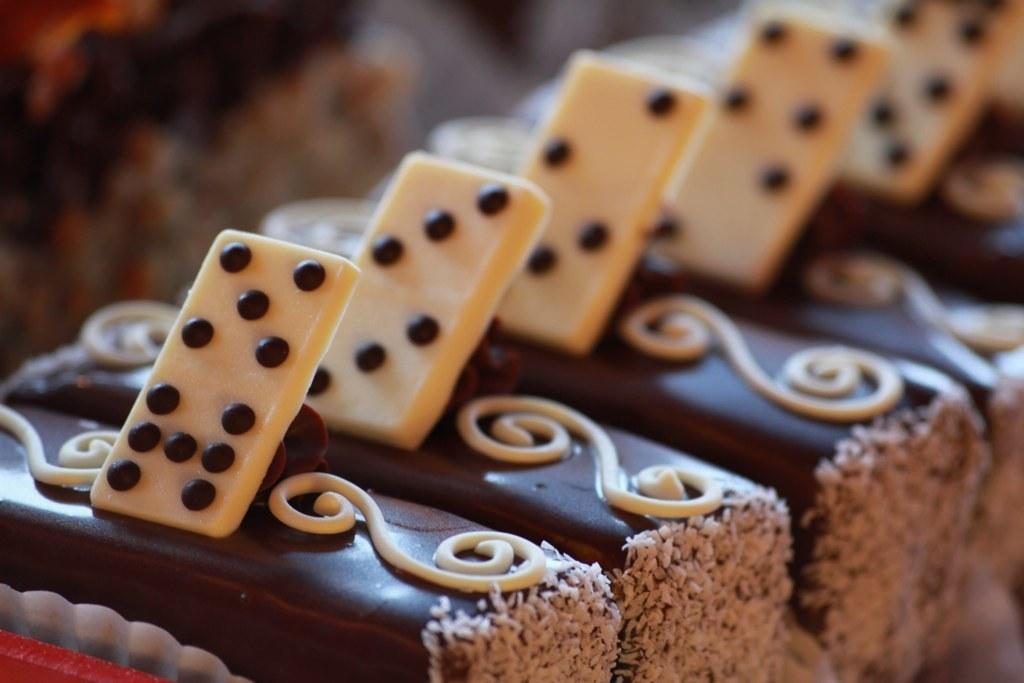Please provide a concise description of this image. In this image we can see desserts arranged in a row. 